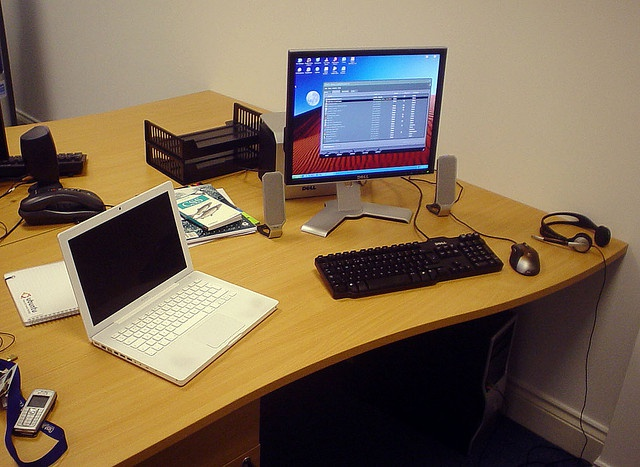Describe the objects in this image and their specific colors. I can see laptop in maroon, black, beige, and tan tones, tv in maroon, black, and darkgray tones, keyboard in maroon, beige, and tan tones, keyboard in maroon, black, and gray tones, and book in maroon, lightyellow, darkgray, and tan tones in this image. 